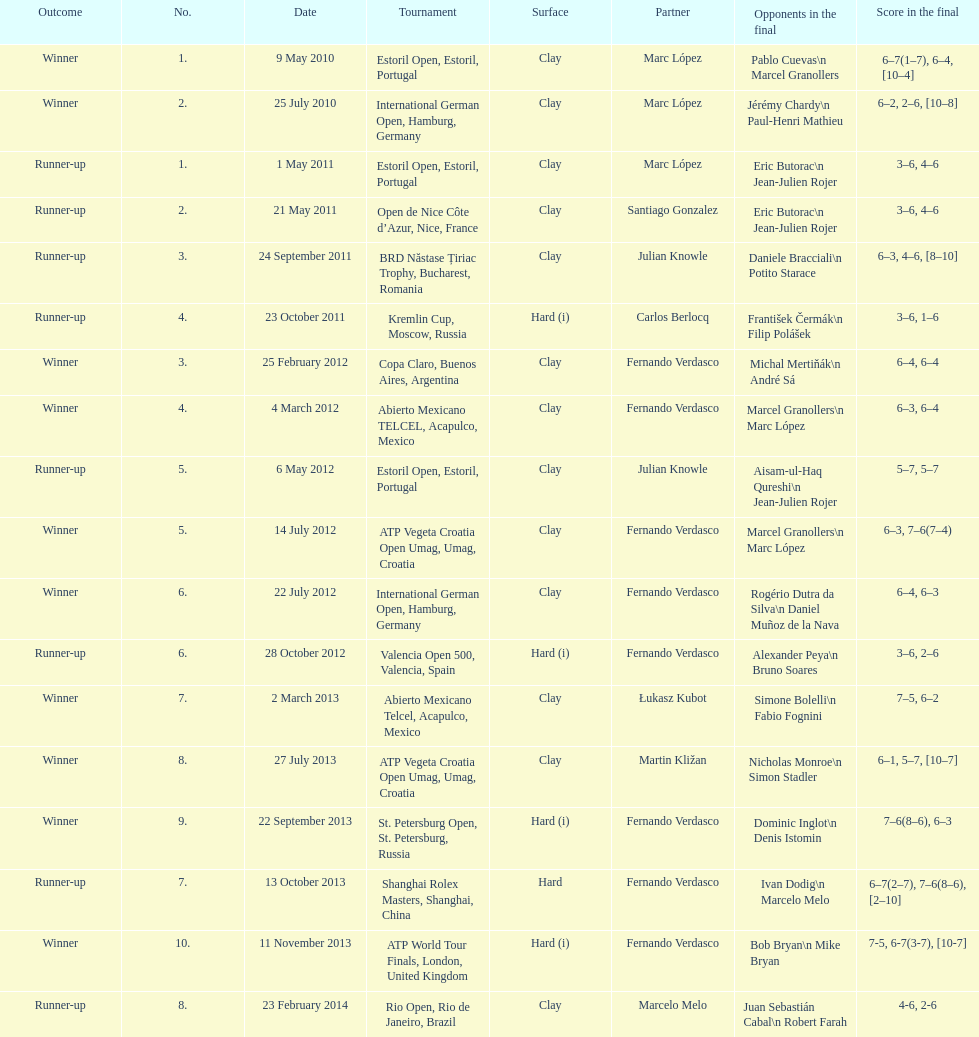What is the number of listed partners from spain? 2. Give me the full table as a dictionary. {'header': ['Outcome', 'No.', 'Date', 'Tournament', 'Surface', 'Partner', 'Opponents in the final', 'Score in the final'], 'rows': [['Winner', '1.', '9 May 2010', 'Estoril Open, Estoril, Portugal', 'Clay', 'Marc López', 'Pablo Cuevas\\n Marcel Granollers', '6–7(1–7), 6–4, [10–4]'], ['Winner', '2.', '25 July 2010', 'International German Open, Hamburg, Germany', 'Clay', 'Marc López', 'Jérémy Chardy\\n Paul-Henri Mathieu', '6–2, 2–6, [10–8]'], ['Runner-up', '1.', '1 May 2011', 'Estoril Open, Estoril, Portugal', 'Clay', 'Marc López', 'Eric Butorac\\n Jean-Julien Rojer', '3–6, 4–6'], ['Runner-up', '2.', '21 May 2011', 'Open de Nice Côte d’Azur, Nice, France', 'Clay', 'Santiago Gonzalez', 'Eric Butorac\\n Jean-Julien Rojer', '3–6, 4–6'], ['Runner-up', '3.', '24 September 2011', 'BRD Năstase Țiriac Trophy, Bucharest, Romania', 'Clay', 'Julian Knowle', 'Daniele Bracciali\\n Potito Starace', '6–3, 4–6, [8–10]'], ['Runner-up', '4.', '23 October 2011', 'Kremlin Cup, Moscow, Russia', 'Hard (i)', 'Carlos Berlocq', 'František Čermák\\n Filip Polášek', '3–6, 1–6'], ['Winner', '3.', '25 February 2012', 'Copa Claro, Buenos Aires, Argentina', 'Clay', 'Fernando Verdasco', 'Michal Mertiňák\\n André Sá', '6–4, 6–4'], ['Winner', '4.', '4 March 2012', 'Abierto Mexicano TELCEL, Acapulco, Mexico', 'Clay', 'Fernando Verdasco', 'Marcel Granollers\\n Marc López', '6–3, 6–4'], ['Runner-up', '5.', '6 May 2012', 'Estoril Open, Estoril, Portugal', 'Clay', 'Julian Knowle', 'Aisam-ul-Haq Qureshi\\n Jean-Julien Rojer', '5–7, 5–7'], ['Winner', '5.', '14 July 2012', 'ATP Vegeta Croatia Open Umag, Umag, Croatia', 'Clay', 'Fernando Verdasco', 'Marcel Granollers\\n Marc López', '6–3, 7–6(7–4)'], ['Winner', '6.', '22 July 2012', 'International German Open, Hamburg, Germany', 'Clay', 'Fernando Verdasco', 'Rogério Dutra da Silva\\n Daniel Muñoz de la Nava', '6–4, 6–3'], ['Runner-up', '6.', '28 October 2012', 'Valencia Open 500, Valencia, Spain', 'Hard (i)', 'Fernando Verdasco', 'Alexander Peya\\n Bruno Soares', '3–6, 2–6'], ['Winner', '7.', '2 March 2013', 'Abierto Mexicano Telcel, Acapulco, Mexico', 'Clay', 'Łukasz Kubot', 'Simone Bolelli\\n Fabio Fognini', '7–5, 6–2'], ['Winner', '8.', '27 July 2013', 'ATP Vegeta Croatia Open Umag, Umag, Croatia', 'Clay', 'Martin Kližan', 'Nicholas Monroe\\n Simon Stadler', '6–1, 5–7, [10–7]'], ['Winner', '9.', '22 September 2013', 'St. Petersburg Open, St. Petersburg, Russia', 'Hard (i)', 'Fernando Verdasco', 'Dominic Inglot\\n Denis Istomin', '7–6(8–6), 6–3'], ['Runner-up', '7.', '13 October 2013', 'Shanghai Rolex Masters, Shanghai, China', 'Hard', 'Fernando Verdasco', 'Ivan Dodig\\n Marcelo Melo', '6–7(2–7), 7–6(8–6), [2–10]'], ['Winner', '10.', '11 November 2013', 'ATP World Tour Finals, London, United Kingdom', 'Hard (i)', 'Fernando Verdasco', 'Bob Bryan\\n Mike Bryan', '7-5, 6-7(3-7), [10-7]'], ['Runner-up', '8.', '23 February 2014', 'Rio Open, Rio de Janeiro, Brazil', 'Clay', 'Marcelo Melo', 'Juan Sebastián Cabal\\n Robert Farah', '4-6, 2-6']]} 